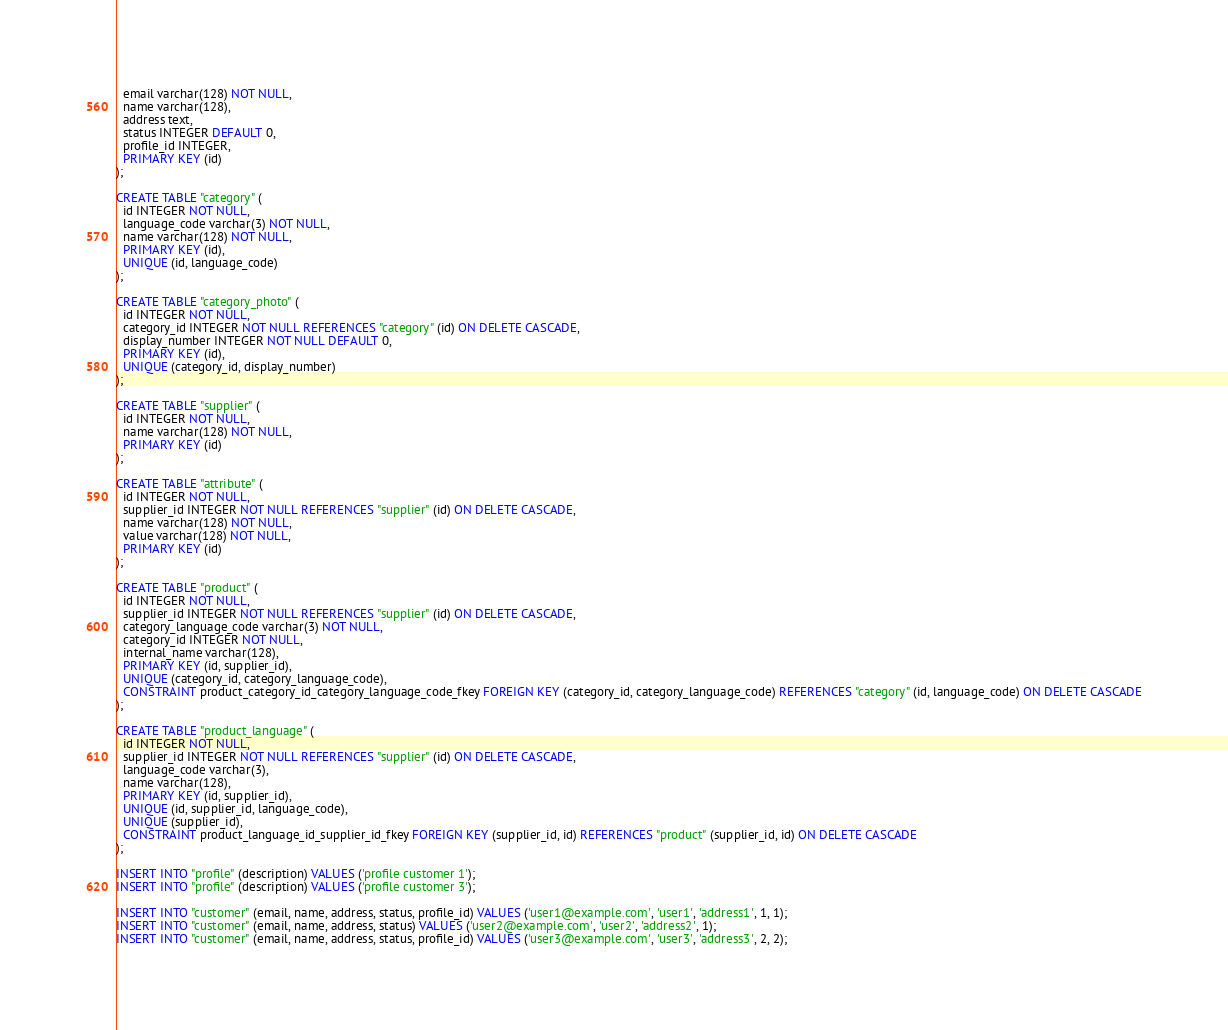Convert code to text. <code><loc_0><loc_0><loc_500><loc_500><_SQL_>  email varchar(128) NOT NULL,
  name varchar(128),
  address text,
  status INTEGER DEFAULT 0,
  profile_id INTEGER,
  PRIMARY KEY (id)
);

CREATE TABLE "category" (
  id INTEGER NOT NULL,
  language_code varchar(3) NOT NULL,
  name varchar(128) NOT NULL,
  PRIMARY KEY (id),
  UNIQUE (id, language_code)
);

CREATE TABLE "category_photo" (
  id INTEGER NOT NULL,
  category_id INTEGER NOT NULL REFERENCES "category" (id) ON DELETE CASCADE,
  display_number INTEGER NOT NULL DEFAULT 0,
  PRIMARY KEY (id),
  UNIQUE (category_id, display_number)
);

CREATE TABLE "supplier" (
  id INTEGER NOT NULL,
  name varchar(128) NOT NULL,
  PRIMARY KEY (id)
);

CREATE TABLE "attribute" (
  id INTEGER NOT NULL,
  supplier_id INTEGER NOT NULL REFERENCES "supplier" (id) ON DELETE CASCADE,
  name varchar(128) NOT NULL,
  value varchar(128) NOT NULL,
  PRIMARY KEY (id)
);

CREATE TABLE "product" (
  id INTEGER NOT NULL,
  supplier_id INTEGER NOT NULL REFERENCES "supplier" (id) ON DELETE CASCADE,
  category_language_code varchar(3) NOT NULL,
  category_id INTEGER NOT NULL,
  internal_name varchar(128),
  PRIMARY KEY (id, supplier_id),
  UNIQUE (category_id, category_language_code),
  CONSTRAINT product_category_id_category_language_code_fkey FOREIGN KEY (category_id, category_language_code) REFERENCES "category" (id, language_code) ON DELETE CASCADE
);

CREATE TABLE "product_language" (
  id INTEGER NOT NULL,
  supplier_id INTEGER NOT NULL REFERENCES "supplier" (id) ON DELETE CASCADE,
  language_code varchar(3),
  name varchar(128),
  PRIMARY KEY (id, supplier_id),
  UNIQUE (id, supplier_id, language_code),
  UNIQUE (supplier_id),
  CONSTRAINT product_language_id_supplier_id_fkey FOREIGN KEY (supplier_id, id) REFERENCES "product" (supplier_id, id) ON DELETE CASCADE
);

INSERT INTO "profile" (description) VALUES ('profile customer 1');
INSERT INTO "profile" (description) VALUES ('profile customer 3');

INSERT INTO "customer" (email, name, address, status, profile_id) VALUES ('user1@example.com', 'user1', 'address1', 1, 1);
INSERT INTO "customer" (email, name, address, status) VALUES ('user2@example.com', 'user2', 'address2', 1);
INSERT INTO "customer" (email, name, address, status, profile_id) VALUES ('user3@example.com', 'user3', 'address3', 2, 2);
</code> 